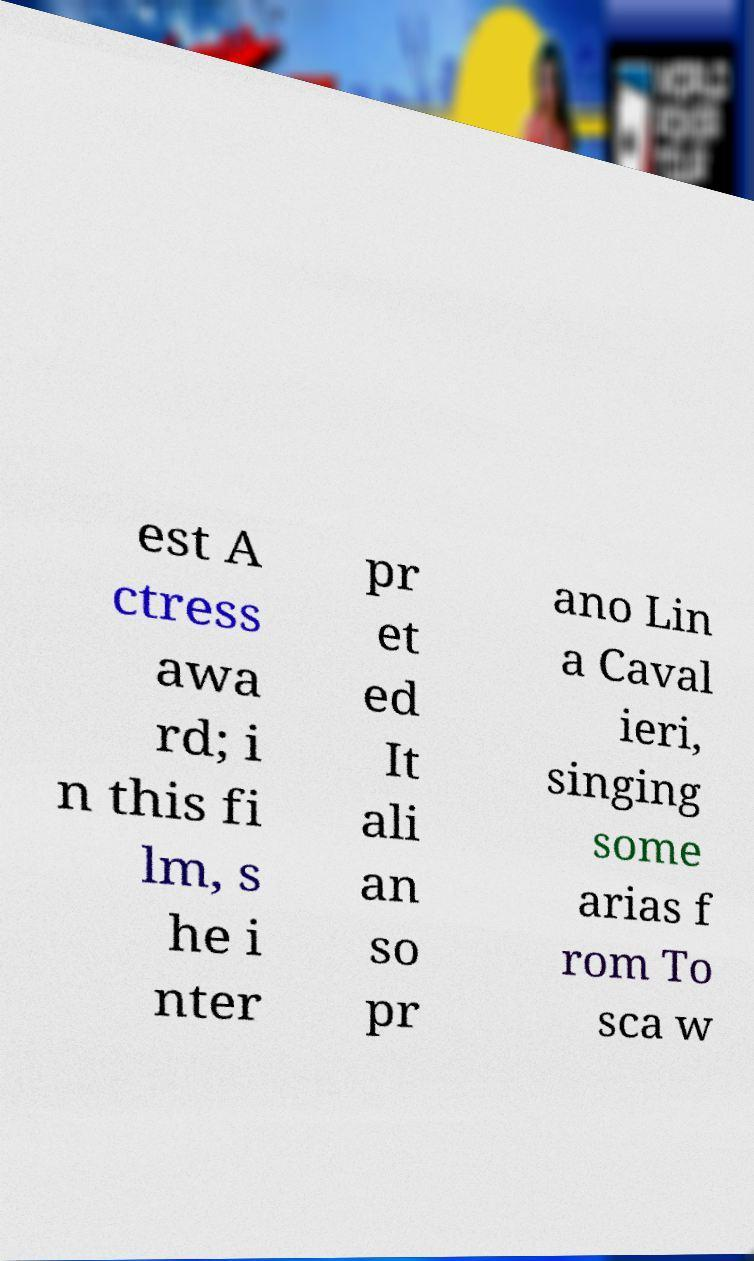Can you read and provide the text displayed in the image?This photo seems to have some interesting text. Can you extract and type it out for me? est A ctress awa rd; i n this fi lm, s he i nter pr et ed It ali an so pr ano Lin a Caval ieri, singing some arias f rom To sca w 